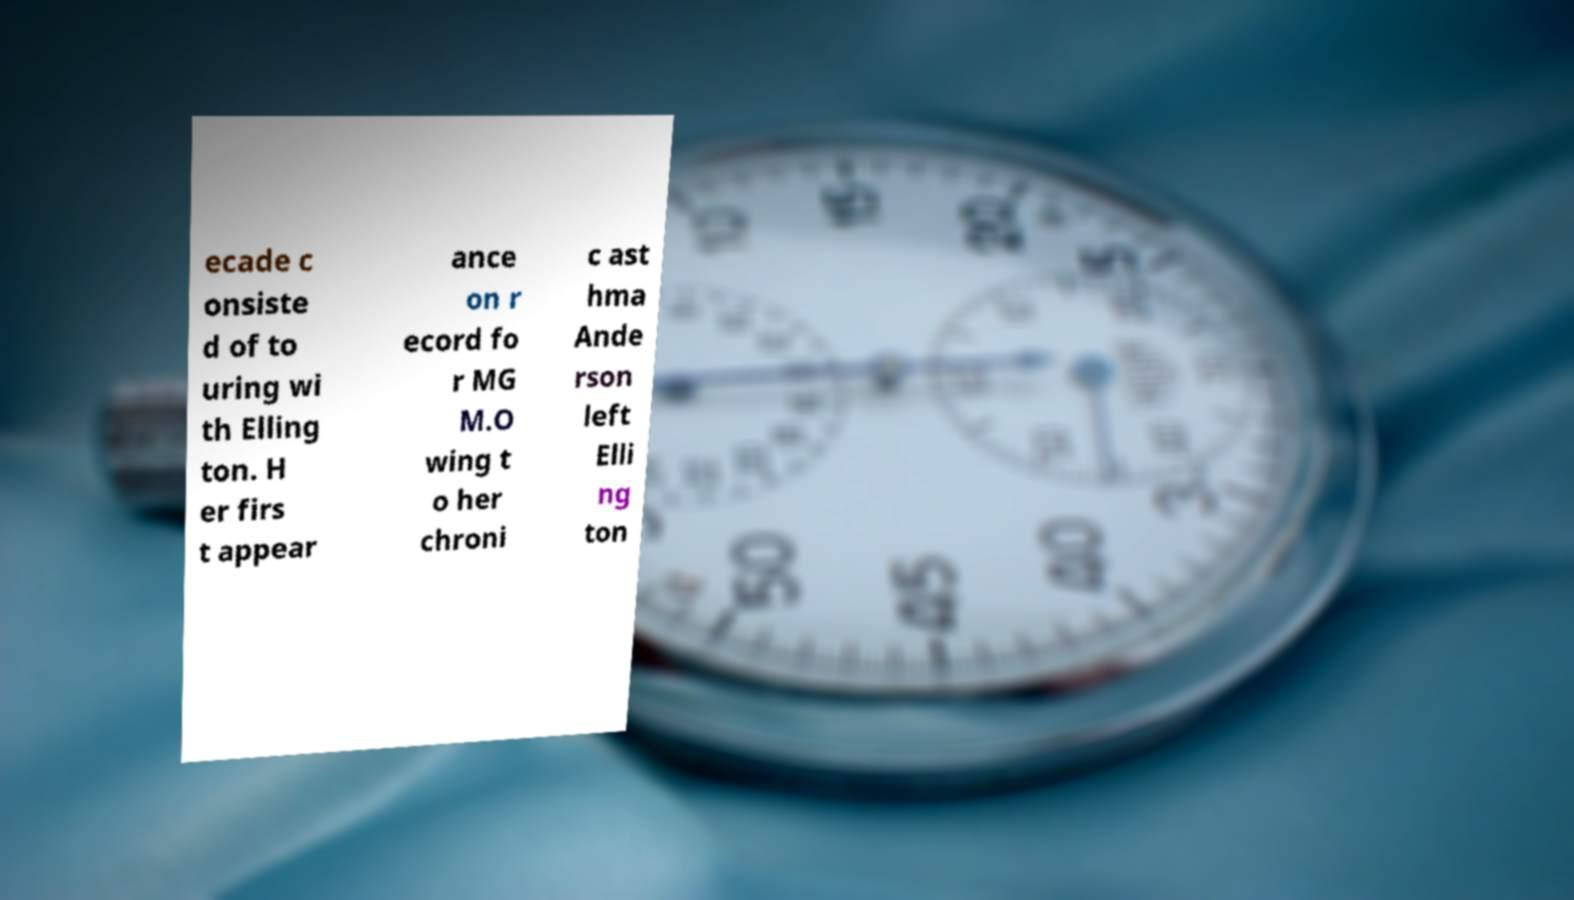Please read and relay the text visible in this image. What does it say? ecade c onsiste d of to uring wi th Elling ton. H er firs t appear ance on r ecord fo r MG M.O wing t o her chroni c ast hma Ande rson left Elli ng ton 